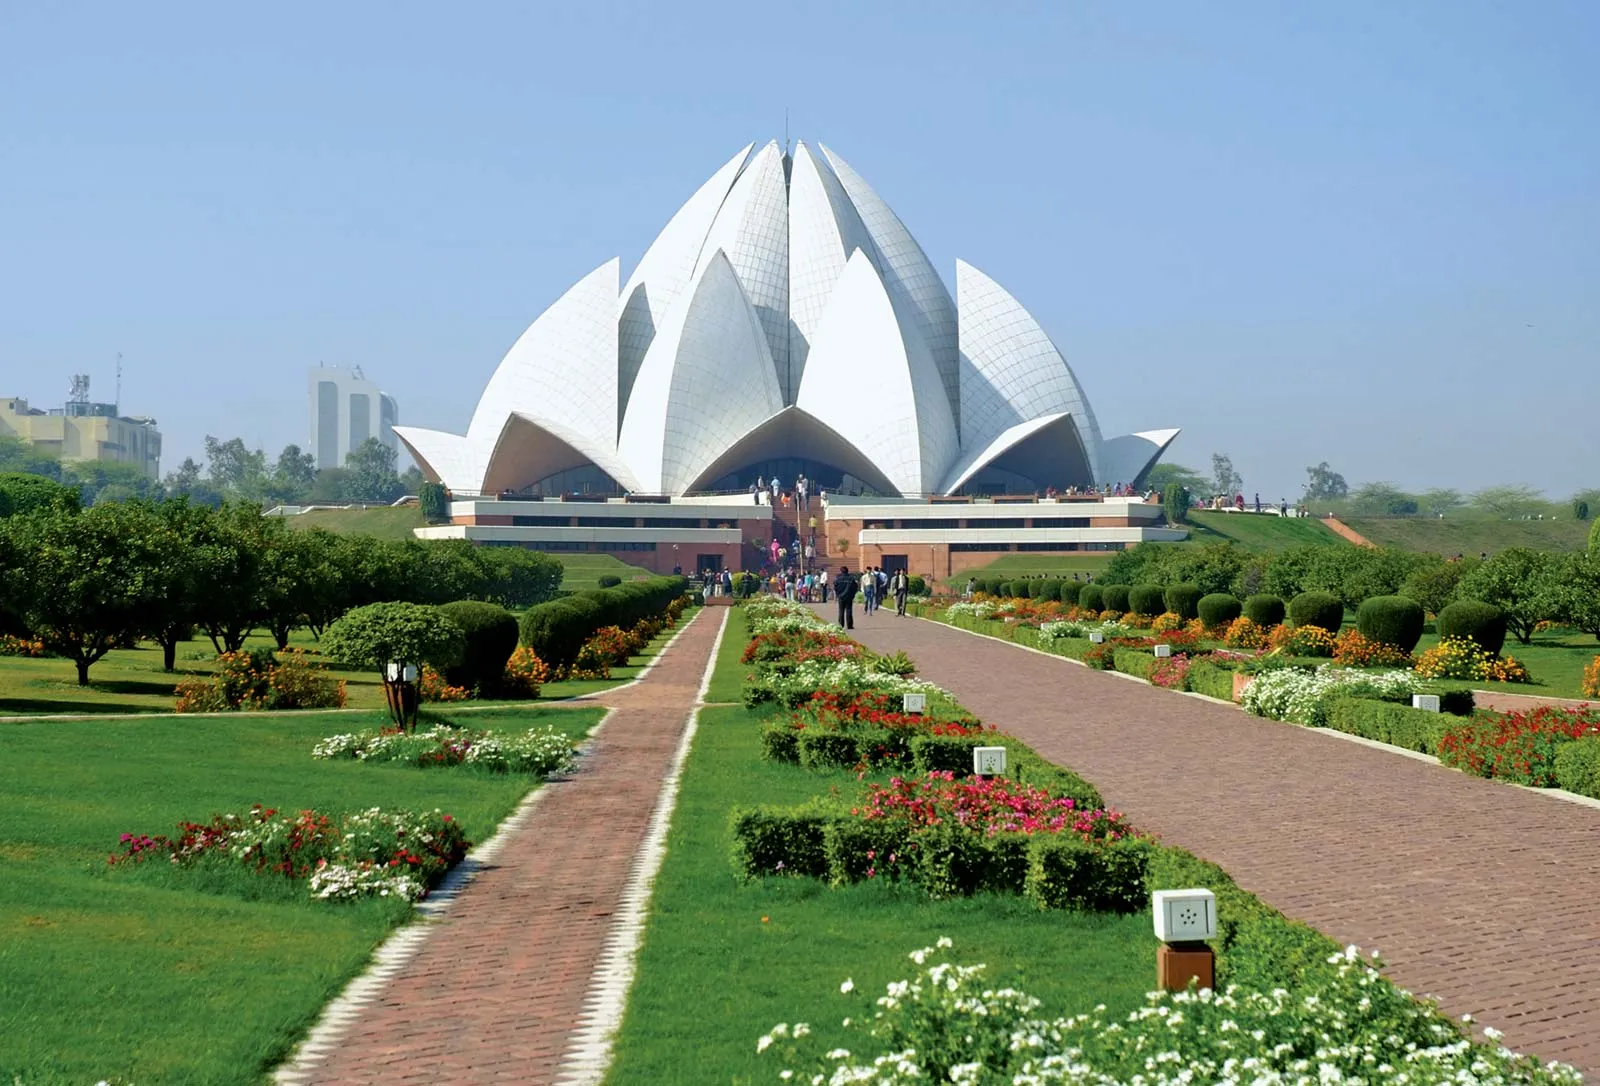What is the significance of the garden surrounding the Lotus Temple? The gardens around the Lotus Temple play a crucial role in its design and spiritual ambiance. Covering 26 acres, these meticulously maintained gardens enhance the temple's theme of purity and perfection. Each section of the garden is designed to complement the temple's shape and aesthetic, creating a harmonious visual experience that begins even before entering the temple. Moreover, the gardens serve as a physical representation of order and beauty, aiming to evoke a state of meditation and peace for visitors as they approach the temple. 